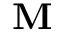<formula> <loc_0><loc_0><loc_500><loc_500>M</formula> 